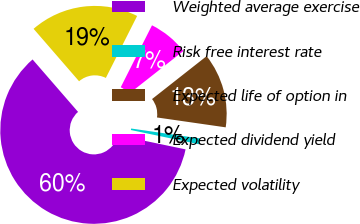Convert chart to OTSL. <chart><loc_0><loc_0><loc_500><loc_500><pie_chart><fcel>Weighted average exercise<fcel>Risk free interest rate<fcel>Expected life of option in<fcel>Expected dividend yield<fcel>Expected volatility<nl><fcel>60.34%<fcel>1.01%<fcel>12.88%<fcel>6.95%<fcel>18.81%<nl></chart> 